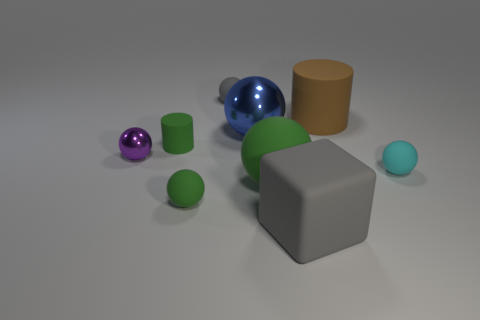Is there any other thing that has the same shape as the big gray object?
Your response must be concise. No. There is a rubber cylinder in front of the large metal object; is it the same color as the big matte thing that is to the left of the large gray block?
Your answer should be compact. Yes. There is a green cylinder; are there any tiny cyan rubber balls behind it?
Your answer should be compact. No. How many large green things have the same shape as the big blue metal object?
Ensure brevity in your answer.  1. What color is the big matte thing on the right side of the gray rubber thing to the right of the sphere behind the big brown cylinder?
Make the answer very short. Brown. Is the tiny sphere that is behind the brown cylinder made of the same material as the small green object that is in front of the tiny metallic thing?
Your answer should be very brief. Yes. What number of things are tiny gray spheres that are behind the cyan object or brown things?
Your response must be concise. 2. How many things are blue metal cubes or spheres behind the brown matte cylinder?
Your answer should be compact. 1. What number of purple objects have the same size as the cyan rubber ball?
Make the answer very short. 1. Are there fewer big gray objects that are behind the purple metal ball than small things that are left of the big shiny sphere?
Provide a succinct answer. Yes. 